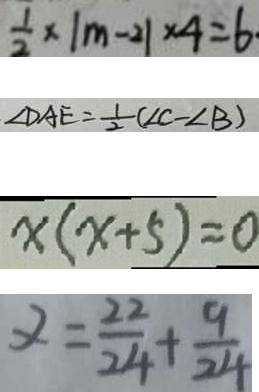<formula> <loc_0><loc_0><loc_500><loc_500>\frac { 1 } { 2 } \times \vert m - 2 \vert \times 4 = 6 
 \angle D A E = \frac { 1 } { 2 } ( \angle C - \angle B ) 
 x ( x + 5 ) = 0 
 x = \frac { 2 2 } { 2 4 } + \frac { 9 } { 2 4 }</formula> 